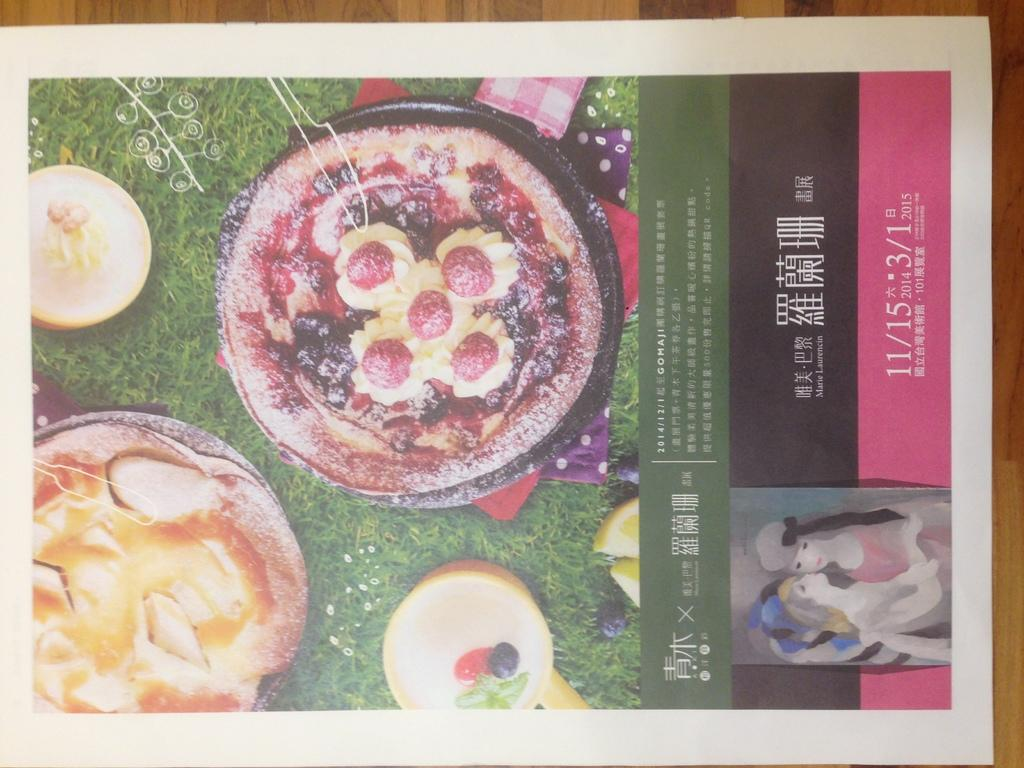Provide a one-sentence caption for the provided image. 2014/12/1 Gomaji is written below food choices in this advert. 